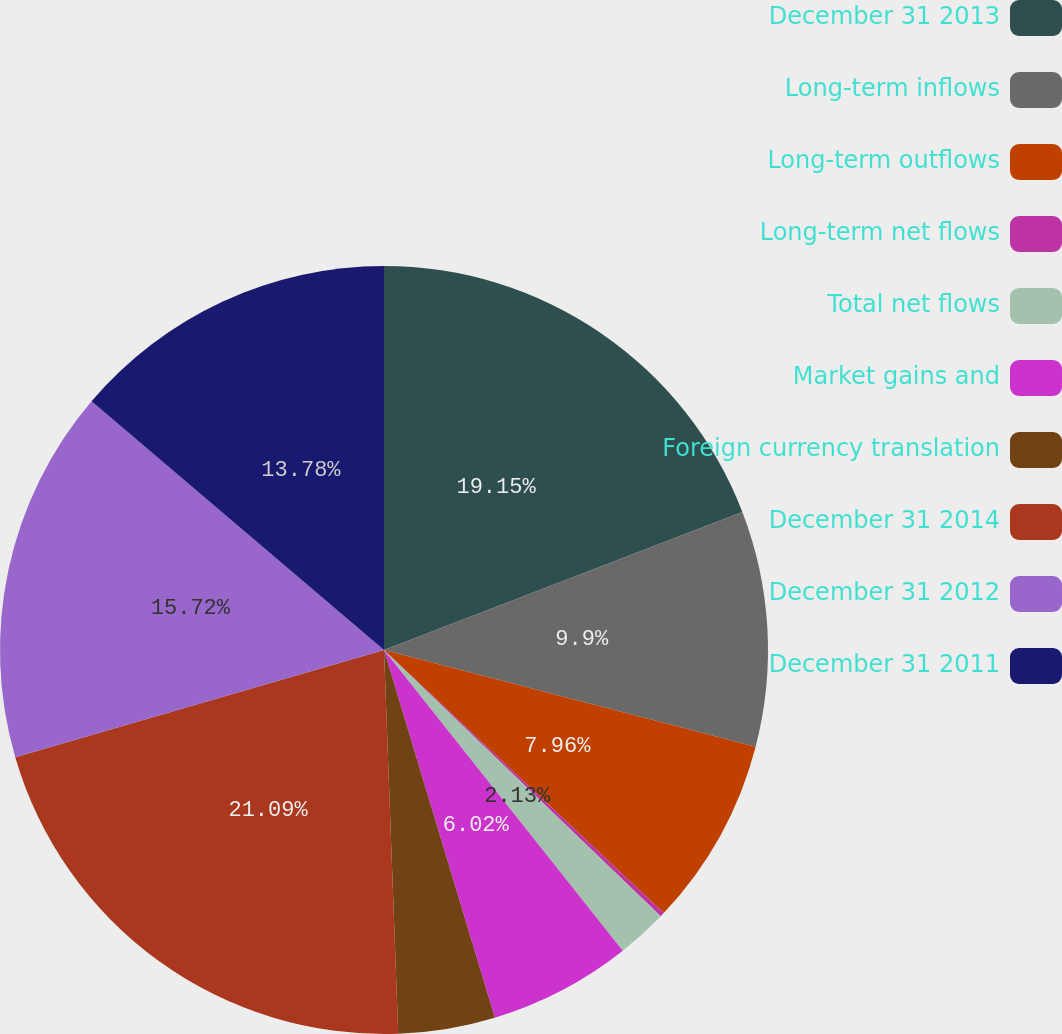Convert chart to OTSL. <chart><loc_0><loc_0><loc_500><loc_500><pie_chart><fcel>December 31 2013<fcel>Long-term inflows<fcel>Long-term outflows<fcel>Long-term net flows<fcel>Total net flows<fcel>Market gains and<fcel>Foreign currency translation<fcel>December 31 2014<fcel>December 31 2012<fcel>December 31 2011<nl><fcel>19.15%<fcel>9.9%<fcel>7.96%<fcel>0.18%<fcel>2.13%<fcel>6.02%<fcel>4.07%<fcel>21.09%<fcel>15.72%<fcel>13.78%<nl></chart> 